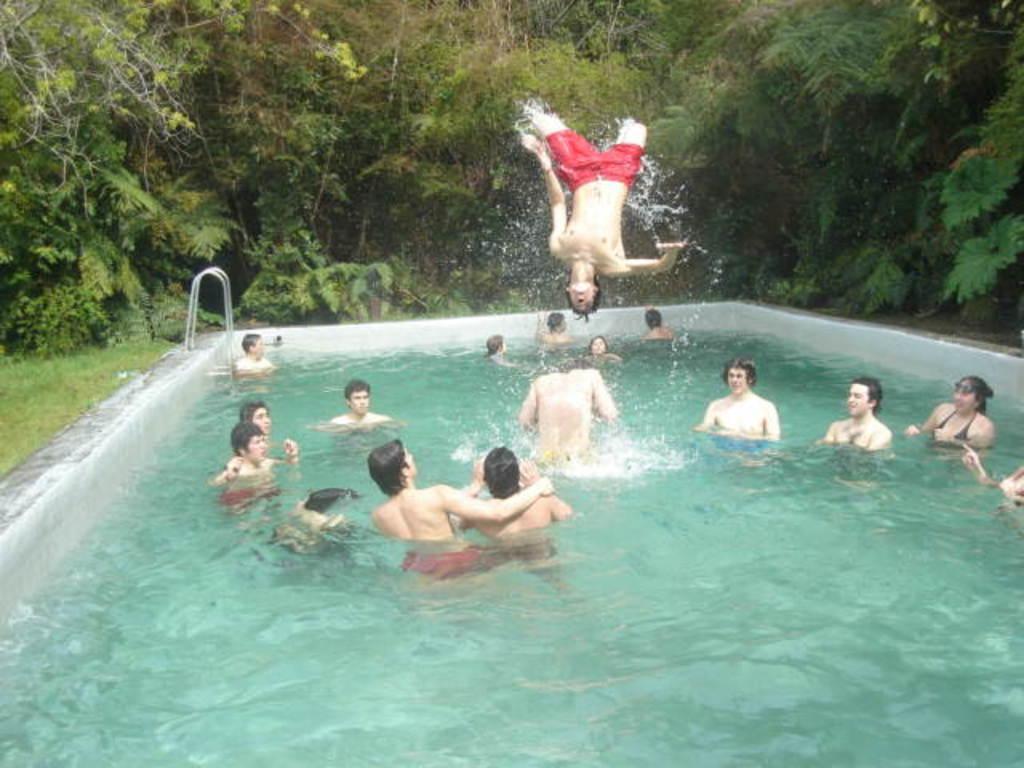Describe this image in one or two sentences. In the image we can see there are many people in the swimming pool and one person is jumping. There are trees and grass. 